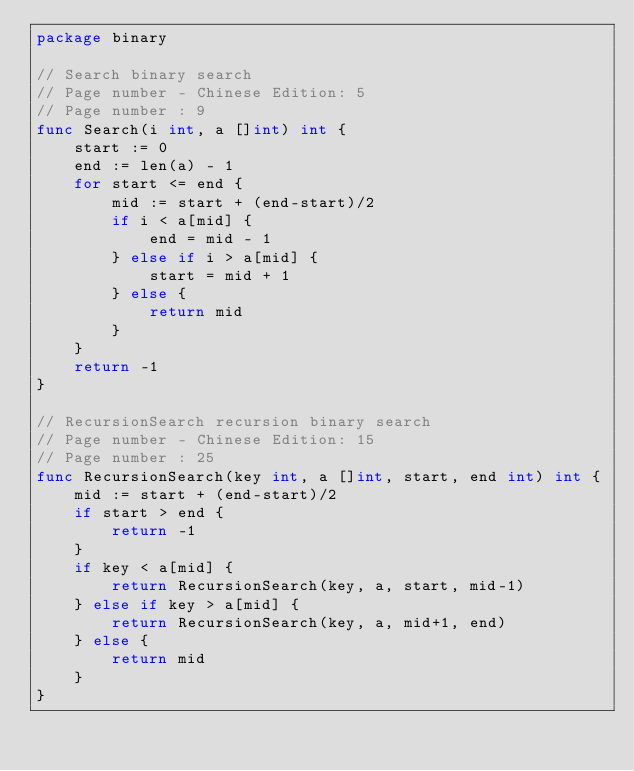Convert code to text. <code><loc_0><loc_0><loc_500><loc_500><_Go_>package binary

// Search binary search
// Page number - Chinese Edition: 5
// Page number : 9
func Search(i int, a []int) int {
	start := 0
	end := len(a) - 1
	for start <= end {
		mid := start + (end-start)/2
		if i < a[mid] {
			end = mid - 1
		} else if i > a[mid] {
			start = mid + 1
		} else {
			return mid
		}
	}
	return -1
}

// RecursionSearch recursion binary search
// Page number - Chinese Edition: 15
// Page number : 25
func RecursionSearch(key int, a []int, start, end int) int {
	mid := start + (end-start)/2
	if start > end {
		return -1
	}
	if key < a[mid] {
		return RecursionSearch(key, a, start, mid-1)
	} else if key > a[mid] {
		return RecursionSearch(key, a, mid+1, end)
	} else {
		return mid
	}
}
</code> 